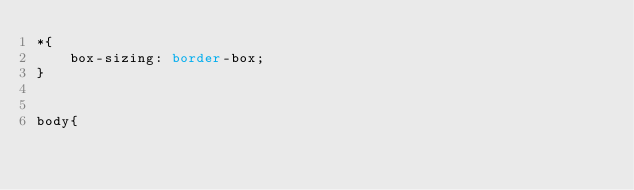<code> <loc_0><loc_0><loc_500><loc_500><_CSS_>*{
    box-sizing: border-box;
}


body{</code> 